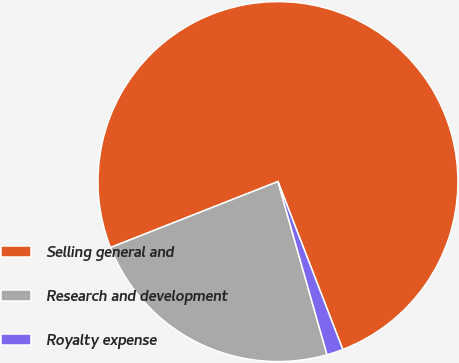Convert chart to OTSL. <chart><loc_0><loc_0><loc_500><loc_500><pie_chart><fcel>Selling general and<fcel>Research and development<fcel>Royalty expense<nl><fcel>75.11%<fcel>23.42%<fcel>1.47%<nl></chart> 